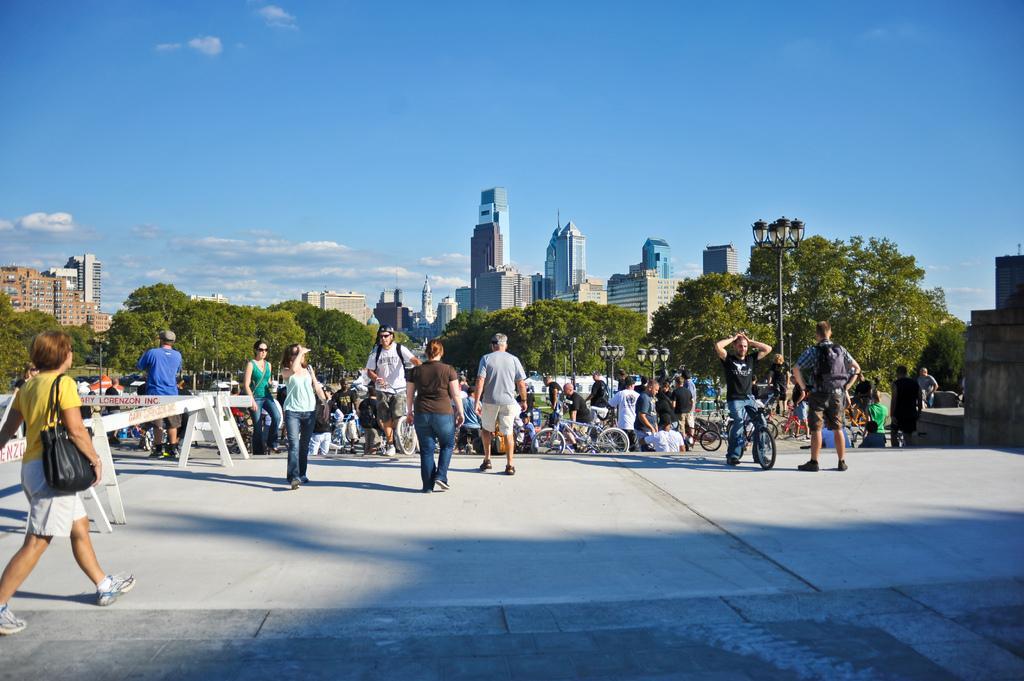Describe this image in one or two sentences. In the middle of the image few people are standing, walking and holding some bicycles. Behind them there are some poles, trees and buildings. At the top of the image there are some clouds in the sky. 